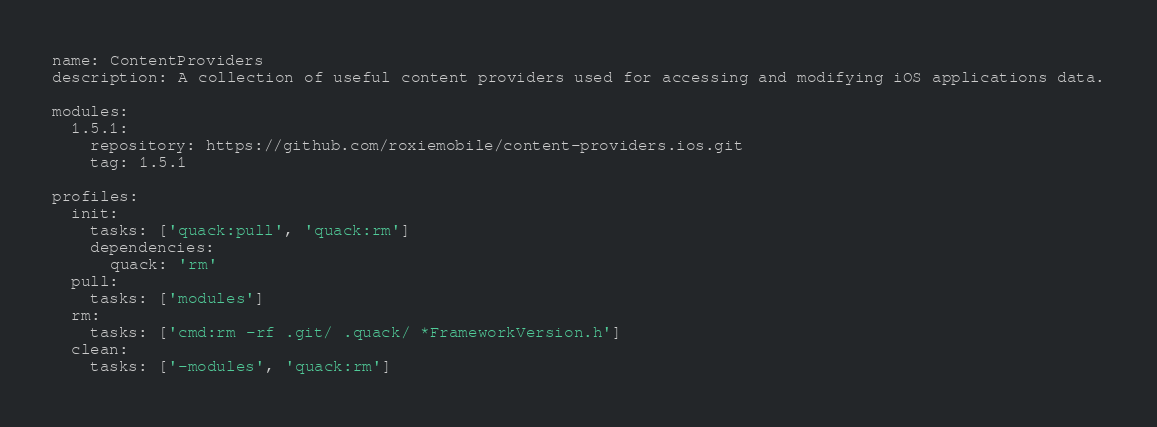Convert code to text. <code><loc_0><loc_0><loc_500><loc_500><_YAML_>name: ContentProviders
description: A collection of useful content providers used for accessing and modifying iOS applications data.

modules:
  1.5.1:
    repository: https://github.com/roxiemobile/content-providers.ios.git
    tag: 1.5.1

profiles:
  init:
    tasks: ['quack:pull', 'quack:rm']
    dependencies:
      quack: 'rm'
  pull:
    tasks: ['modules']
  rm:
    tasks: ['cmd:rm -rf .git/ .quack/ *FrameworkVersion.h']
  clean:
    tasks: ['-modules', 'quack:rm']
</code> 